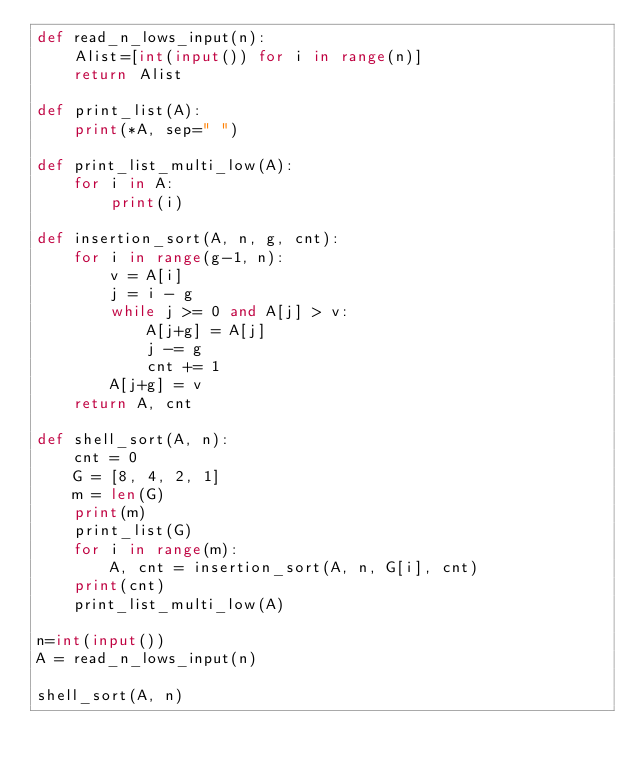Convert code to text. <code><loc_0><loc_0><loc_500><loc_500><_Python_>def read_n_lows_input(n):
    Alist=[int(input()) for i in range(n)]
    return Alist

def print_list(A):
    print(*A, sep=" ")

def print_list_multi_low(A):
    for i in A:
        print(i)
    
def insertion_sort(A, n, g, cnt):
    for i in range(g-1, n):
        v = A[i]
        j = i - g
        while j >= 0 and A[j] > v:
            A[j+g] = A[j]
            j -= g
            cnt += 1
        A[j+g] = v
    return A, cnt

def shell_sort(A, n):
    cnt = 0
    G = [8, 4, 2, 1]
    m = len(G)
    print(m)
    print_list(G)
    for i in range(m):
        A, cnt = insertion_sort(A, n, G[i], cnt)
    print(cnt)
    print_list_multi_low(A)

n=int(input())
A = read_n_lows_input(n)

shell_sort(A, n)

</code> 